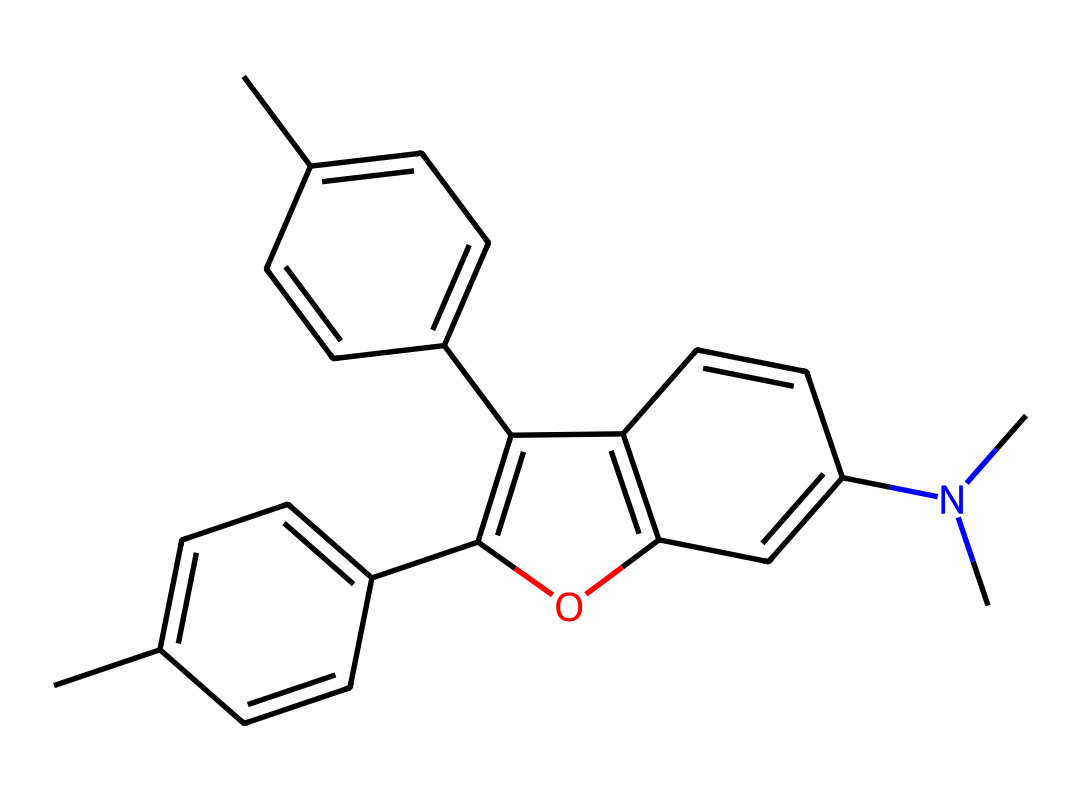how many carbon atoms are present in this compound? By analyzing the SMILES representation, we can count the number of 'C' characters, which indicates carbon atoms. In this structure, there are 22 'C' characters totaling 22 carbon atoms.
Answer: 22 what functional group is present in this molecule? The structure contains a hydroxyl group (-OH) as indicated by the presence of the oxygen atom bonded to a carbon in the ring, visible in the second part of the SMILES string. This indicates that it has a phenolic structure, a typical feature in pigment molecules.
Answer: hydroxyl how many double bonds are in this structure? In the provided SMILES, we look for '=' characters which denote double bonds. By counting these in the chemical structure, we find there are 5 double bonds present in the molecule.
Answer: 5 what type of compound is described by this structure? The structure illustrated is categorized as an aliphatic compound because it contains long chains of carbon atoms with various functional groups, yet exhibits properties typical of aromatic compounds due to its cyclic structures. However, its classification is based on its carbon backbone primarily.
Answer: aliphatic which part of the molecule contributes to the color properties for digital displays? The chromophore is responsible for the color properties. In this structure, the conjugated double bonds within the ring systems allow for electronic transitions that absorb specific wavelengths of light, creating color.
Answer: chromophore is there a nitrogen atom in this compound? By reviewing the SMILES representation, we find "N" indicating the presence of a nitrogen atom, specifically in the tertiary amine functional group present in the structure.
Answer: yes 